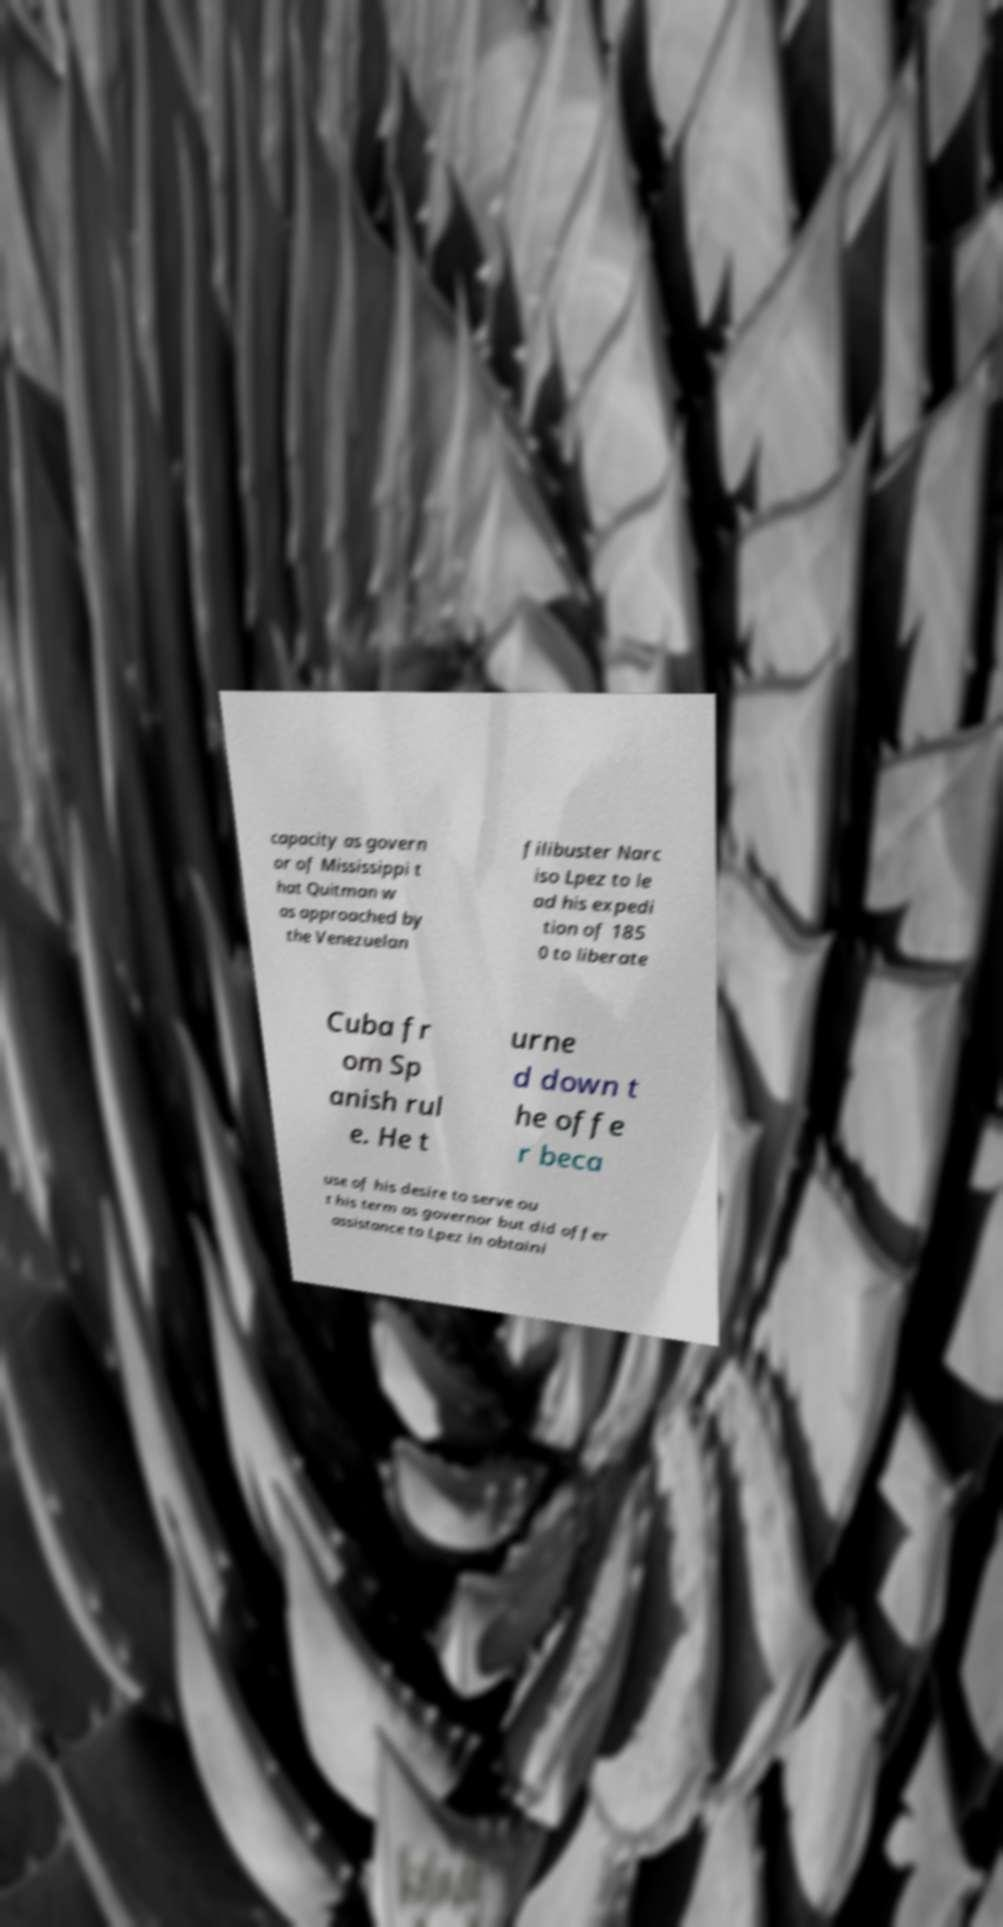Please identify and transcribe the text found in this image. capacity as govern or of Mississippi t hat Quitman w as approached by the Venezuelan filibuster Narc iso Lpez to le ad his expedi tion of 185 0 to liberate Cuba fr om Sp anish rul e. He t urne d down t he offe r beca use of his desire to serve ou t his term as governor but did offer assistance to Lpez in obtaini 